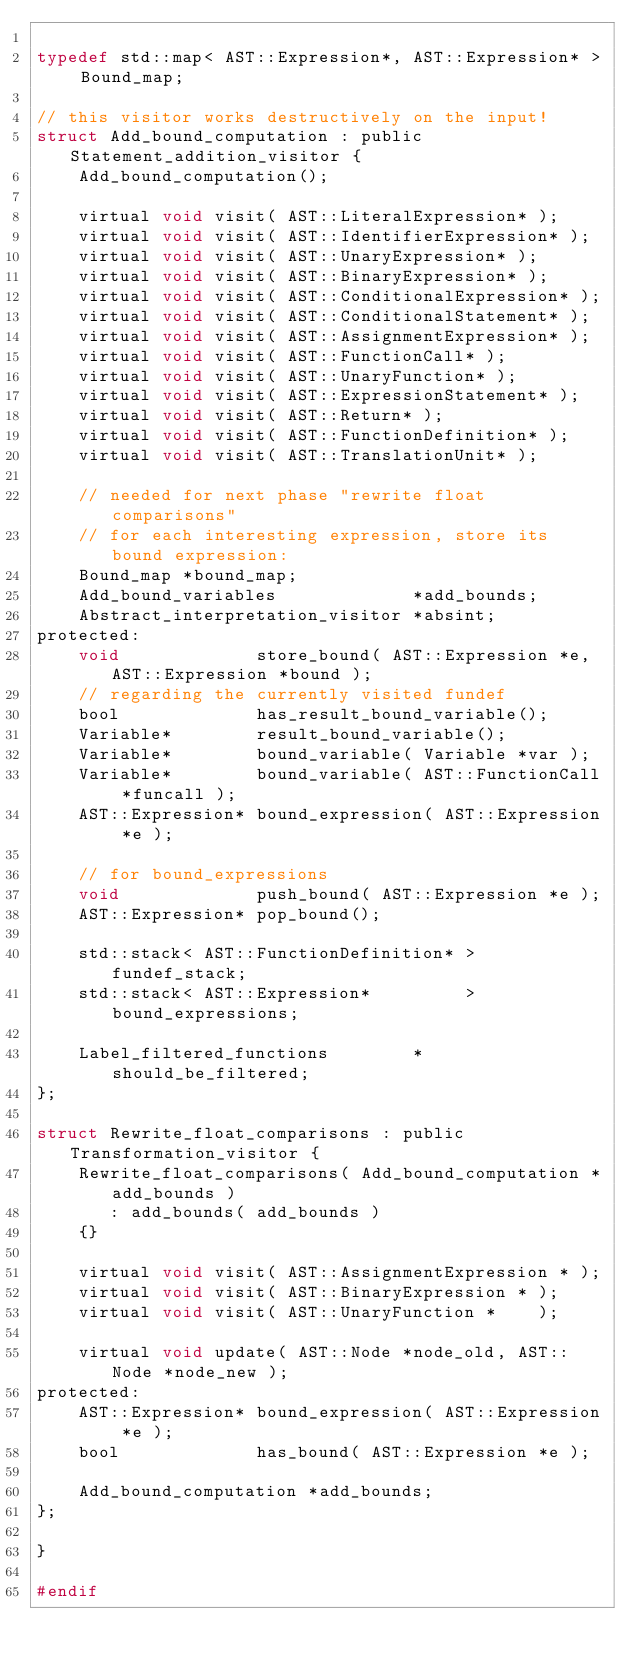<code> <loc_0><loc_0><loc_500><loc_500><_C_>
typedef std::map< AST::Expression*, AST::Expression* > Bound_map;

// this visitor works destructively on the input!
struct Add_bound_computation : public Statement_addition_visitor {
    Add_bound_computation();

    virtual void visit( AST::LiteralExpression* );
    virtual void visit( AST::IdentifierExpression* );
    virtual void visit( AST::UnaryExpression* );
    virtual void visit( AST::BinaryExpression* );
    virtual void visit( AST::ConditionalExpression* );
    virtual void visit( AST::ConditionalStatement* );
    virtual void visit( AST::AssignmentExpression* );
    virtual void visit( AST::FunctionCall* );
    virtual void visit( AST::UnaryFunction* );
    virtual void visit( AST::ExpressionStatement* );
    virtual void visit( AST::Return* );
    virtual void visit( AST::FunctionDefinition* );
    virtual void visit( AST::TranslationUnit* );

    // needed for next phase "rewrite float comparisons"
    // for each interesting expression, store its bound expression:
    Bound_map *bound_map;
    Add_bound_variables             *add_bounds;
    Abstract_interpretation_visitor *absint;
protected:
    void             store_bound( AST::Expression *e, AST::Expression *bound );
    // regarding the currently visited fundef
    bool             has_result_bound_variable();
    Variable*        result_bound_variable();
    Variable*        bound_variable( Variable *var );
    Variable*        bound_variable( AST::FunctionCall *funcall );
    AST::Expression* bound_expression( AST::Expression *e );

    // for bound_expressions
    void             push_bound( AST::Expression *e );
    AST::Expression* pop_bound();

    std::stack< AST::FunctionDefinition* >         fundef_stack;
    std::stack< AST::Expression*         >         bound_expressions;

    Label_filtered_functions        *should_be_filtered;
};

struct Rewrite_float_comparisons : public Transformation_visitor {
    Rewrite_float_comparisons( Add_bound_computation *add_bounds )
       : add_bounds( add_bounds )
    {}

    virtual void visit( AST::AssignmentExpression * );
    virtual void visit( AST::BinaryExpression * );
    virtual void visit( AST::UnaryFunction *    );

    virtual void update( AST::Node *node_old, AST::Node *node_new );
protected:
    AST::Expression* bound_expression( AST::Expression *e );
    bool             has_bound( AST::Expression *e );

    Add_bound_computation *add_bounds;
};

}

#endif
</code> 